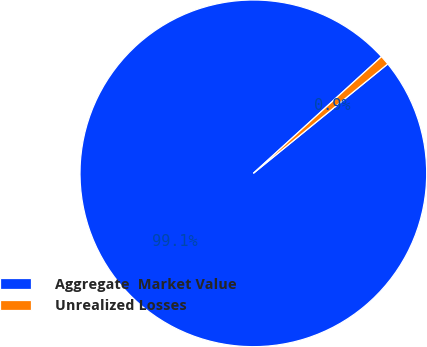Convert chart to OTSL. <chart><loc_0><loc_0><loc_500><loc_500><pie_chart><fcel>Aggregate  Market Value<fcel>Unrealized Losses<nl><fcel>99.12%<fcel>0.88%<nl></chart> 